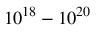<formula> <loc_0><loc_0><loc_500><loc_500>1 0 ^ { 1 8 } - 1 0 ^ { 2 0 }</formula> 